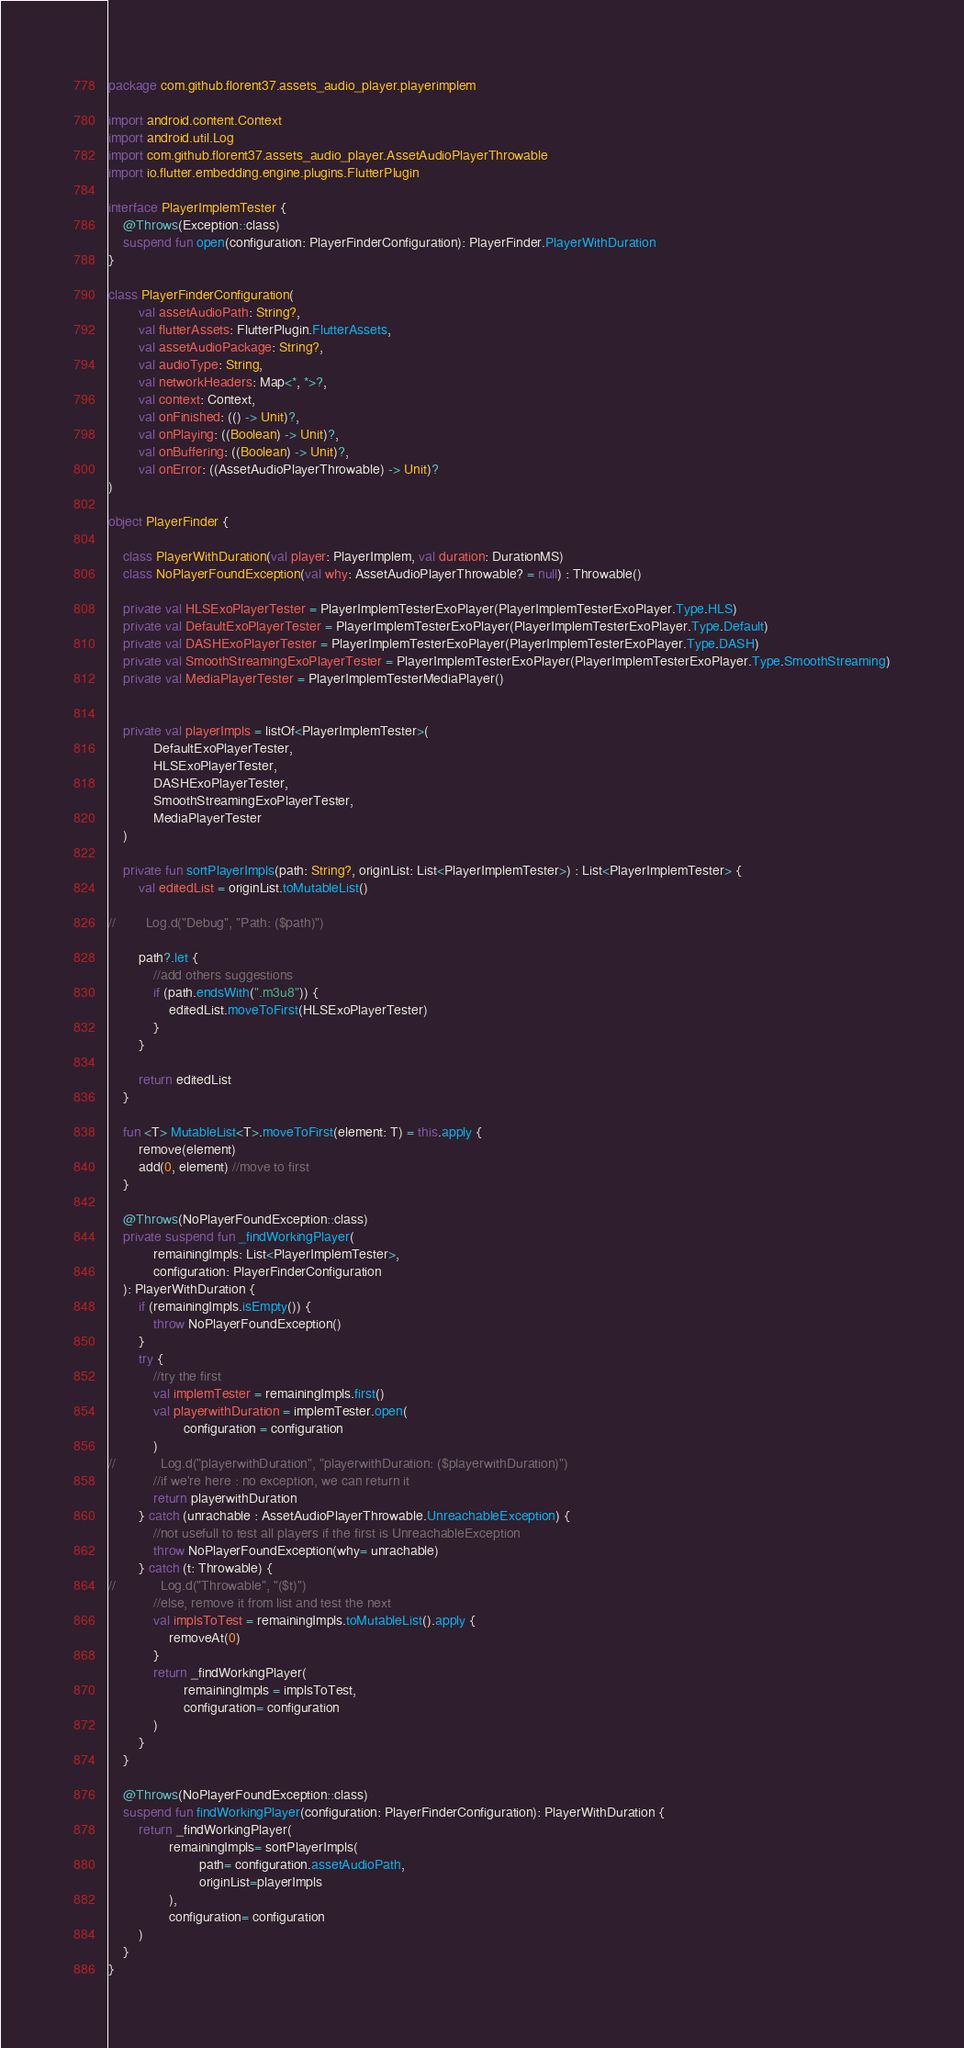<code> <loc_0><loc_0><loc_500><loc_500><_Kotlin_>package com.github.florent37.assets_audio_player.playerimplem

import android.content.Context
import android.util.Log
import com.github.florent37.assets_audio_player.AssetAudioPlayerThrowable
import io.flutter.embedding.engine.plugins.FlutterPlugin

interface PlayerImplemTester {
    @Throws(Exception::class)
    suspend fun open(configuration: PlayerFinderConfiguration): PlayerFinder.PlayerWithDuration
}

class PlayerFinderConfiguration(
        val assetAudioPath: String?,
        val flutterAssets: FlutterPlugin.FlutterAssets,
        val assetAudioPackage: String?,
        val audioType: String,
        val networkHeaders: Map<*, *>?,
        val context: Context,
        val onFinished: (() -> Unit)?,
        val onPlaying: ((Boolean) -> Unit)?,
        val onBuffering: ((Boolean) -> Unit)?,
        val onError: ((AssetAudioPlayerThrowable) -> Unit)?
)

object PlayerFinder {

    class PlayerWithDuration(val player: PlayerImplem, val duration: DurationMS)
    class NoPlayerFoundException(val why: AssetAudioPlayerThrowable? = null) : Throwable()

    private val HLSExoPlayerTester = PlayerImplemTesterExoPlayer(PlayerImplemTesterExoPlayer.Type.HLS)
    private val DefaultExoPlayerTester = PlayerImplemTesterExoPlayer(PlayerImplemTesterExoPlayer.Type.Default)
    private val DASHExoPlayerTester = PlayerImplemTesterExoPlayer(PlayerImplemTesterExoPlayer.Type.DASH)
    private val SmoothStreamingExoPlayerTester = PlayerImplemTesterExoPlayer(PlayerImplemTesterExoPlayer.Type.SmoothStreaming)
    private val MediaPlayerTester = PlayerImplemTesterMediaPlayer()


    private val playerImpls = listOf<PlayerImplemTester>(
            DefaultExoPlayerTester,
            HLSExoPlayerTester,
            DASHExoPlayerTester,
            SmoothStreamingExoPlayerTester,
            MediaPlayerTester
    )

    private fun sortPlayerImpls(path: String?, originList: List<PlayerImplemTester>) : List<PlayerImplemTester> {
        val editedList = originList.toMutableList()

//        Log.d("Debug", "Path: ($path)")

        path?.let {
            //add others suggestions
            if (path.endsWith(".m3u8")) {
                editedList.moveToFirst(HLSExoPlayerTester)
            }
        }

        return editedList
    }

    fun <T> MutableList<T>.moveToFirst(element: T) = this.apply {
        remove(element)
        add(0, element) //move to first
    }

    @Throws(NoPlayerFoundException::class)
    private suspend fun _findWorkingPlayer(
            remainingImpls: List<PlayerImplemTester>,
            configuration: PlayerFinderConfiguration
    ): PlayerWithDuration {
        if (remainingImpls.isEmpty()) {
            throw NoPlayerFoundException()
        }
        try {
            //try the first
            val implemTester = remainingImpls.first()
            val playerwithDuration = implemTester.open(
                    configuration = configuration
            )
//            Log.d("playerwithDuration", "playerwithDuration: ($playerwithDuration)")
            //if we're here : no exception, we can return it
            return playerwithDuration
        } catch (unrachable : AssetAudioPlayerThrowable.UnreachableException) {
            //not usefull to test all players if the first is UnreachableException
            throw NoPlayerFoundException(why= unrachable)
        } catch (t: Throwable) {
//            Log.d("Throwable", "($t)")
            //else, remove it from list and test the next
            val implsToTest = remainingImpls.toMutableList().apply {
                removeAt(0)
            }
            return _findWorkingPlayer(
                    remainingImpls = implsToTest,
                    configuration= configuration
            )
        }
    }

    @Throws(NoPlayerFoundException::class)
    suspend fun findWorkingPlayer(configuration: PlayerFinderConfiguration): PlayerWithDuration {
        return _findWorkingPlayer(
                remainingImpls= sortPlayerImpls(
                        path= configuration.assetAudioPath,
                        originList=playerImpls
                ),
                configuration= configuration
        )
    }
}
</code> 